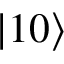Convert formula to latex. <formula><loc_0><loc_0><loc_500><loc_500>\left | 1 0 \right ></formula> 